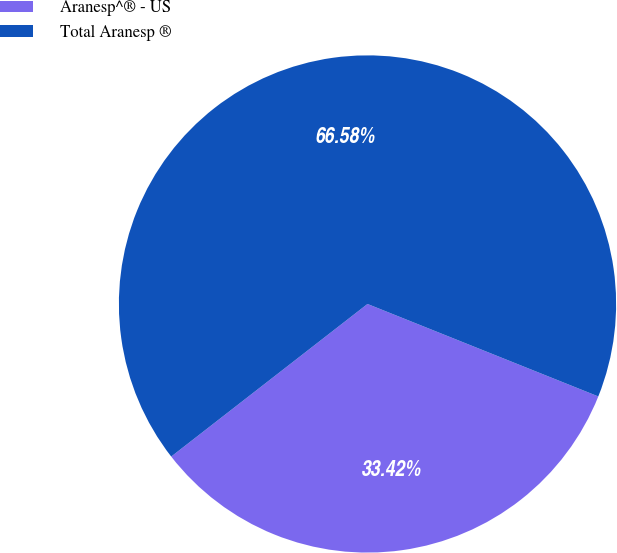Convert chart. <chart><loc_0><loc_0><loc_500><loc_500><pie_chart><fcel>Aranesp^® - US<fcel>Total Aranesp ®<nl><fcel>33.42%<fcel>66.58%<nl></chart> 